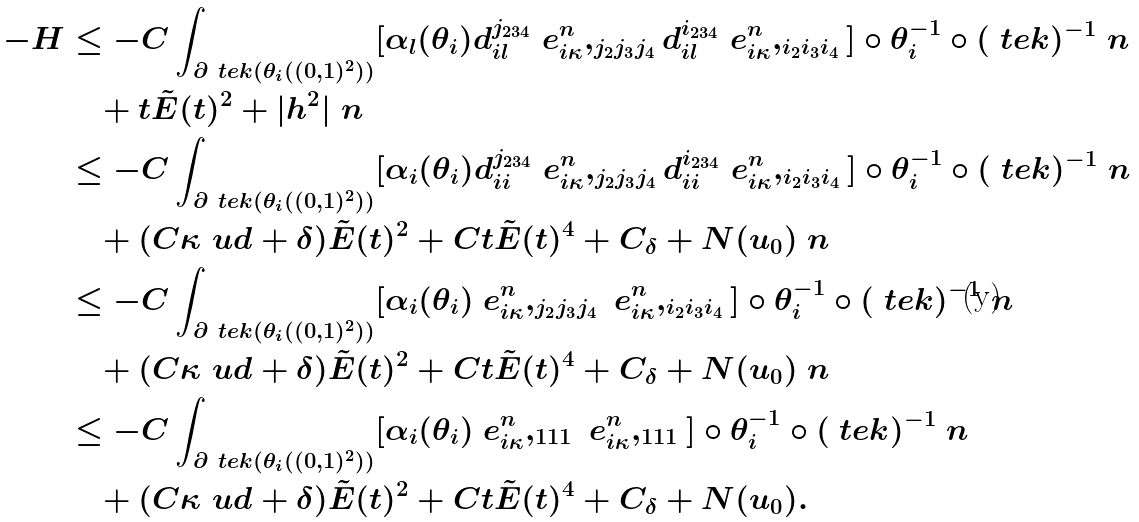Convert formula to latex. <formula><loc_0><loc_0><loc_500><loc_500>- H & \leq - C \int _ { \partial \ t e k ( \theta _ { i } ( ( 0 , 1 ) ^ { 2 } ) ) } [ \alpha _ { l } ( \theta _ { i } ) d _ { i l } ^ { j _ { 2 3 4 } } \ e _ { i \kappa } ^ { n } , _ { j _ { 2 } j _ { 3 } j _ { 4 } } d _ { i l } ^ { i _ { 2 3 4 } } \ e _ { i \kappa } ^ { n } , _ { i _ { 2 } i _ { 3 } i _ { 4 } } ] \circ \theta _ { i } ^ { - 1 } \circ ( \ t e k ) ^ { - 1 } \ n \\ & \quad + t \tilde { E } ( t ) ^ { 2 } + | h ^ { 2 } | \ n \\ & \leq - C \int _ { \partial \ t e k ( \theta _ { i } ( ( 0 , 1 ) ^ { 2 } ) ) } [ \alpha _ { i } ( \theta _ { i } ) d _ { i i } ^ { j _ { 2 3 4 } } \ e _ { i \kappa } ^ { n } , _ { j _ { 2 } j _ { 3 } j _ { 4 } } d _ { i i } ^ { i _ { 2 3 4 } } \ e _ { i \kappa } ^ { n } , _ { i _ { 2 } i _ { 3 } i _ { 4 } } ] \circ \theta _ { i } ^ { - 1 } \circ ( \ t e k ) ^ { - 1 } \ n \\ & \quad + ( C \kappa ^ { \ } u d + \delta ) \tilde { E } ( t ) ^ { 2 } + C t \tilde { E } ( t ) ^ { 4 } + C _ { \delta } + N ( u _ { 0 } ) \ n \\ & \leq - C \int _ { \partial \ t e k ( \theta _ { i } ( ( 0 , 1 ) ^ { 2 } ) ) } [ \alpha _ { i } ( \theta _ { i } ) \ e _ { i \kappa } ^ { n } , _ { j _ { 2 } j _ { 3 } j _ { 4 } } \ e _ { i \kappa } ^ { n } , _ { i _ { 2 } i _ { 3 } i _ { 4 } } ] \circ \theta _ { i } ^ { - 1 } \circ ( \ t e k ) ^ { - 1 } \ n \\ & \quad + ( C \kappa ^ { \ } u d + \delta ) \tilde { E } ( t ) ^ { 2 } + C t \tilde { E } ( t ) ^ { 4 } + C _ { \delta } + N ( u _ { 0 } ) \ n \\ & \leq - C \int _ { \partial \ t e k ( \theta _ { i } ( ( 0 , 1 ) ^ { 2 } ) ) } [ \alpha _ { i } ( \theta _ { i } ) \ e _ { i \kappa } ^ { n } , _ { 1 1 1 } \ e _ { i \kappa } ^ { n } , _ { 1 1 1 } ] \circ \theta _ { i } ^ { - 1 } \circ ( \ t e k ) ^ { - 1 } \ n \\ & \quad + ( C \kappa ^ { \ } u d + \delta ) \tilde { E } ( t ) ^ { 2 } + C t \tilde { E } ( t ) ^ { 4 } + C _ { \delta } + N ( u _ { 0 } ) .</formula> 